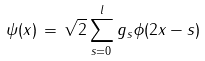Convert formula to latex. <formula><loc_0><loc_0><loc_500><loc_500>\psi ( x ) \, = \, \sqrt { 2 } \sum _ { s = 0 } ^ { l } g _ { s } \phi ( 2 x - s )</formula> 